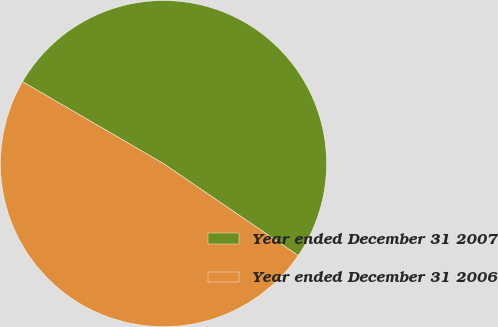Convert chart. <chart><loc_0><loc_0><loc_500><loc_500><pie_chart><fcel>Year ended December 31 2007<fcel>Year ended December 31 2006<nl><fcel>51.15%<fcel>48.85%<nl></chart> 